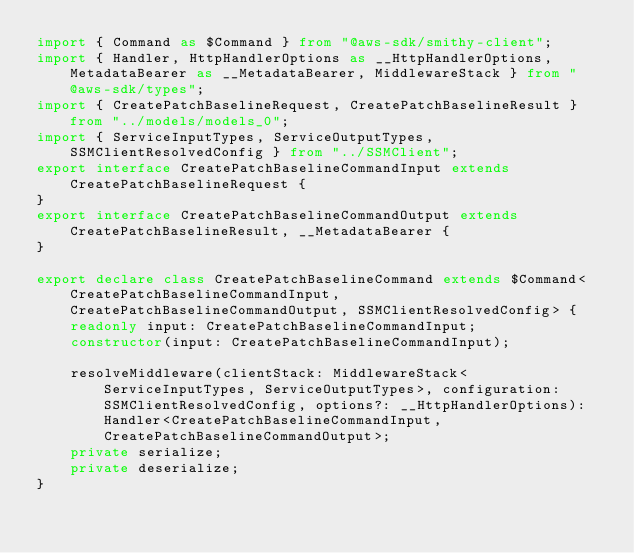<code> <loc_0><loc_0><loc_500><loc_500><_TypeScript_>import { Command as $Command } from "@aws-sdk/smithy-client";
import { Handler, HttpHandlerOptions as __HttpHandlerOptions, MetadataBearer as __MetadataBearer, MiddlewareStack } from "@aws-sdk/types";
import { CreatePatchBaselineRequest, CreatePatchBaselineResult } from "../models/models_0";
import { ServiceInputTypes, ServiceOutputTypes, SSMClientResolvedConfig } from "../SSMClient";
export interface CreatePatchBaselineCommandInput extends CreatePatchBaselineRequest {
}
export interface CreatePatchBaselineCommandOutput extends CreatePatchBaselineResult, __MetadataBearer {
}

export declare class CreatePatchBaselineCommand extends $Command<CreatePatchBaselineCommandInput, CreatePatchBaselineCommandOutput, SSMClientResolvedConfig> {
    readonly input: CreatePatchBaselineCommandInput;
    constructor(input: CreatePatchBaselineCommandInput);
    
    resolveMiddleware(clientStack: MiddlewareStack<ServiceInputTypes, ServiceOutputTypes>, configuration: SSMClientResolvedConfig, options?: __HttpHandlerOptions): Handler<CreatePatchBaselineCommandInput, CreatePatchBaselineCommandOutput>;
    private serialize;
    private deserialize;
}
</code> 